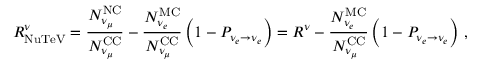Convert formula to latex. <formula><loc_0><loc_0><loc_500><loc_500>R _ { N u T e V } ^ { \nu } = \frac { N _ { \nu _ { \mu } } ^ { N C } } { N _ { \nu _ { \mu } } ^ { C C } } - \frac { N _ { \nu _ { e } } ^ { M C } } { N _ { \nu _ { \mu } } ^ { C C } } \left ( 1 - P _ { \nu _ { e } \to \nu _ { e } } \right ) = R ^ { \nu } - \frac { N _ { \nu _ { e } } ^ { M C } } { N _ { \nu _ { \mu } } ^ { C C } } \left ( 1 - P _ { \nu _ { e } \to \nu _ { e } } \right ) \, ,</formula> 